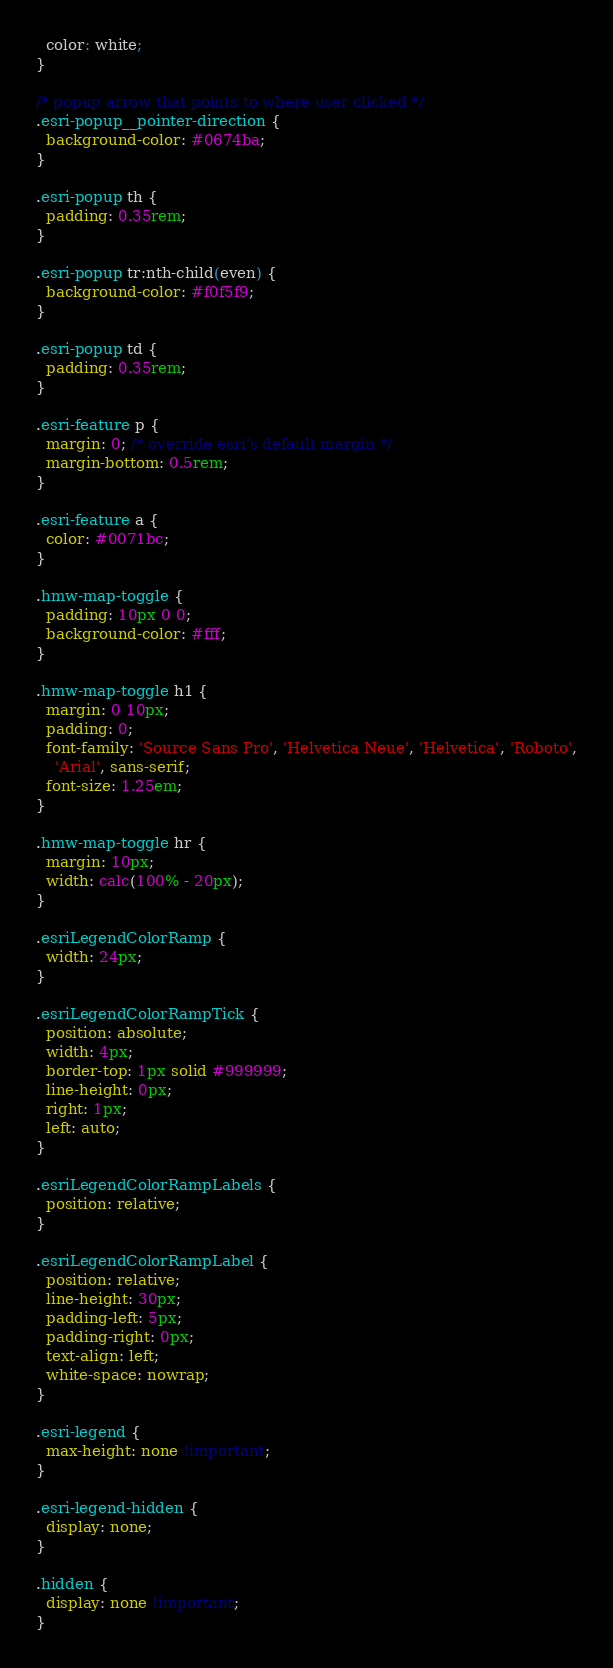Convert code to text. <code><loc_0><loc_0><loc_500><loc_500><_CSS_>  color: white;
}

/* popup arrow that points to where user clicked */
.esri-popup__pointer-direction {
  background-color: #0674ba;
}

.esri-popup th {
  padding: 0.35rem;
}

.esri-popup tr:nth-child(even) {
  background-color: #f0f5f9;
}

.esri-popup td {
  padding: 0.35rem;
}

.esri-feature p {
  margin: 0; /* override esri's default margin */
  margin-bottom: 0.5rem;
}

.esri-feature a {
  color: #0071bc;
}

.hmw-map-toggle {
  padding: 10px 0 0;
  background-color: #fff;
}

.hmw-map-toggle h1 {
  margin: 0 10px;
  padding: 0;
  font-family: 'Source Sans Pro', 'Helvetica Neue', 'Helvetica', 'Roboto',
    'Arial', sans-serif;
  font-size: 1.25em;
}

.hmw-map-toggle hr {
  margin: 10px;
  width: calc(100% - 20px);
}

.esriLegendColorRamp {
  width: 24px;
}

.esriLegendColorRampTick {
  position: absolute;
  width: 4px;
  border-top: 1px solid #999999;
  line-height: 0px;
  right: 1px;
  left: auto;
}

.esriLegendColorRampLabels {
  position: relative;
}

.esriLegendColorRampLabel {
  position: relative;
  line-height: 30px;
  padding-left: 5px;
  padding-right: 0px;
  text-align: left;
  white-space: nowrap;
}

.esri-legend {
  max-height: none !important;
}

.esri-legend-hidden {
  display: none;
}

.hidden {
  display: none !important;
}
</code> 